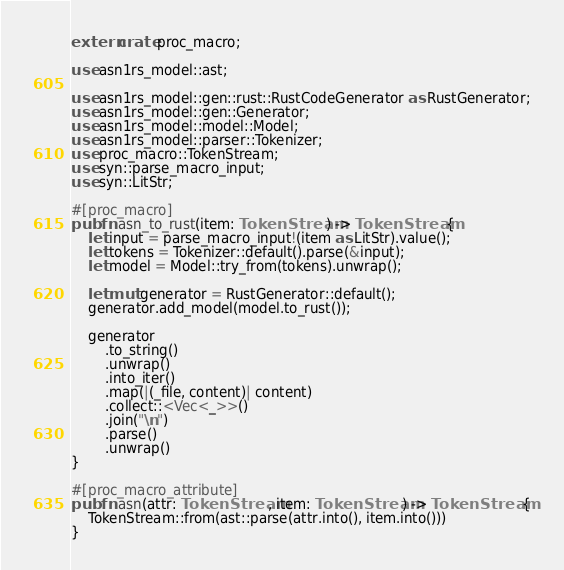<code> <loc_0><loc_0><loc_500><loc_500><_Rust_>extern crate proc_macro;

use asn1rs_model::ast;

use asn1rs_model::gen::rust::RustCodeGenerator as RustGenerator;
use asn1rs_model::gen::Generator;
use asn1rs_model::model::Model;
use asn1rs_model::parser::Tokenizer;
use proc_macro::TokenStream;
use syn::parse_macro_input;
use syn::LitStr;

#[proc_macro]
pub fn asn_to_rust(item: TokenStream) -> TokenStream {
    let input = parse_macro_input!(item as LitStr).value();
    let tokens = Tokenizer::default().parse(&input);
    let model = Model::try_from(tokens).unwrap();

    let mut generator = RustGenerator::default();
    generator.add_model(model.to_rust());

    generator
        .to_string()
        .unwrap()
        .into_iter()
        .map(|(_file, content)| content)
        .collect::<Vec<_>>()
        .join("\n")
        .parse()
        .unwrap()
}

#[proc_macro_attribute]
pub fn asn(attr: TokenStream, item: TokenStream) -> TokenStream {
    TokenStream::from(ast::parse(attr.into(), item.into()))
}
</code> 